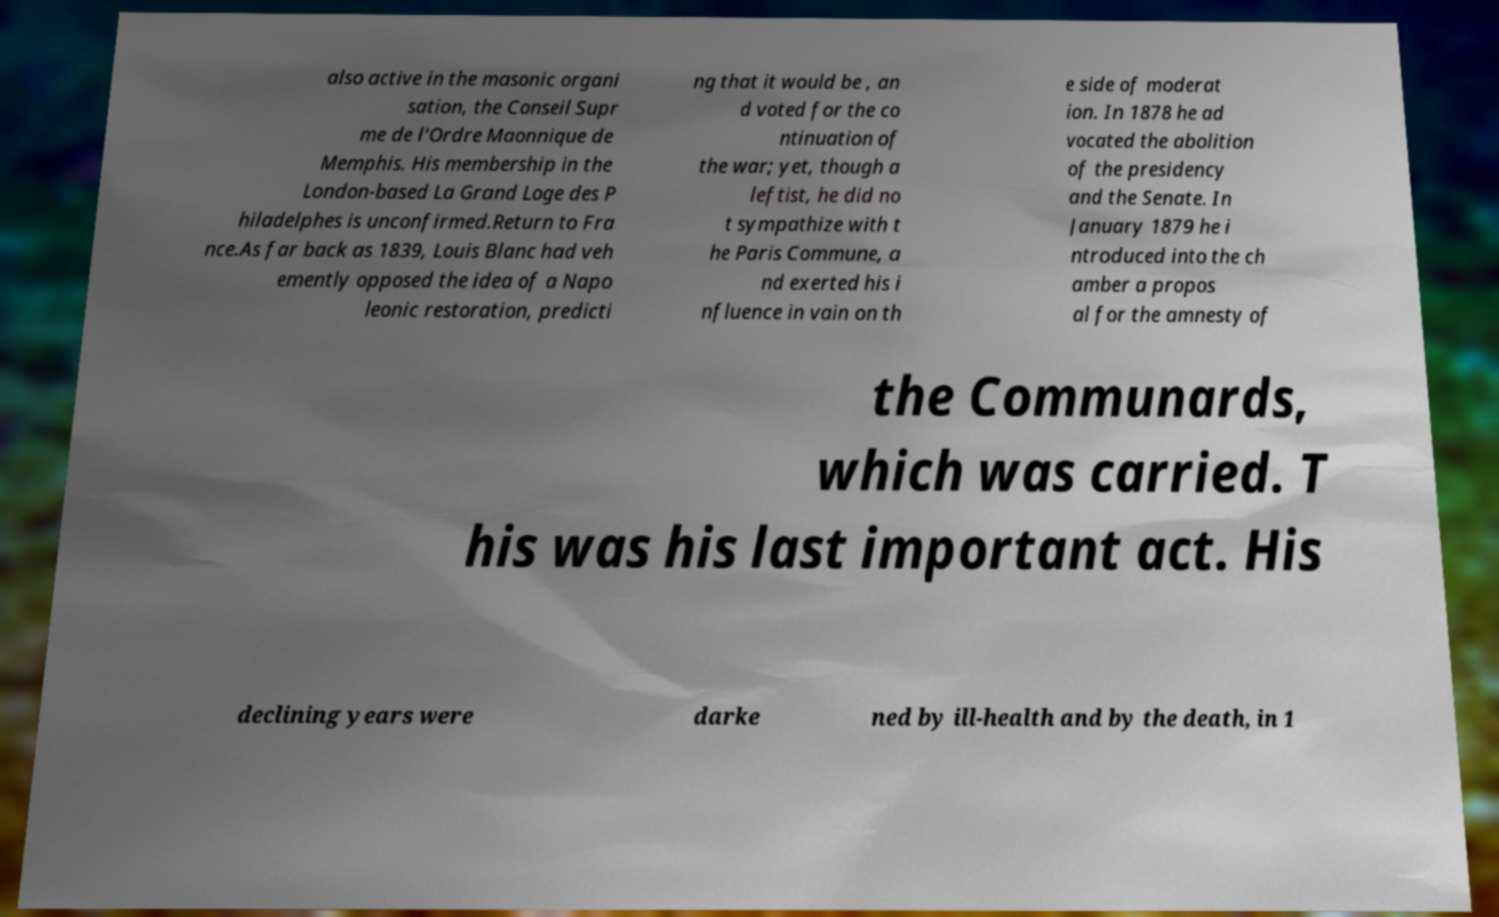There's text embedded in this image that I need extracted. Can you transcribe it verbatim? also active in the masonic organi sation, the Conseil Supr me de l'Ordre Maonnique de Memphis. His membership in the London-based La Grand Loge des P hiladelphes is unconfirmed.Return to Fra nce.As far back as 1839, Louis Blanc had veh emently opposed the idea of a Napo leonic restoration, predicti ng that it would be , an d voted for the co ntinuation of the war; yet, though a leftist, he did no t sympathize with t he Paris Commune, a nd exerted his i nfluence in vain on th e side of moderat ion. In 1878 he ad vocated the abolition of the presidency and the Senate. In January 1879 he i ntroduced into the ch amber a propos al for the amnesty of the Communards, which was carried. T his was his last important act. His declining years were darke ned by ill-health and by the death, in 1 